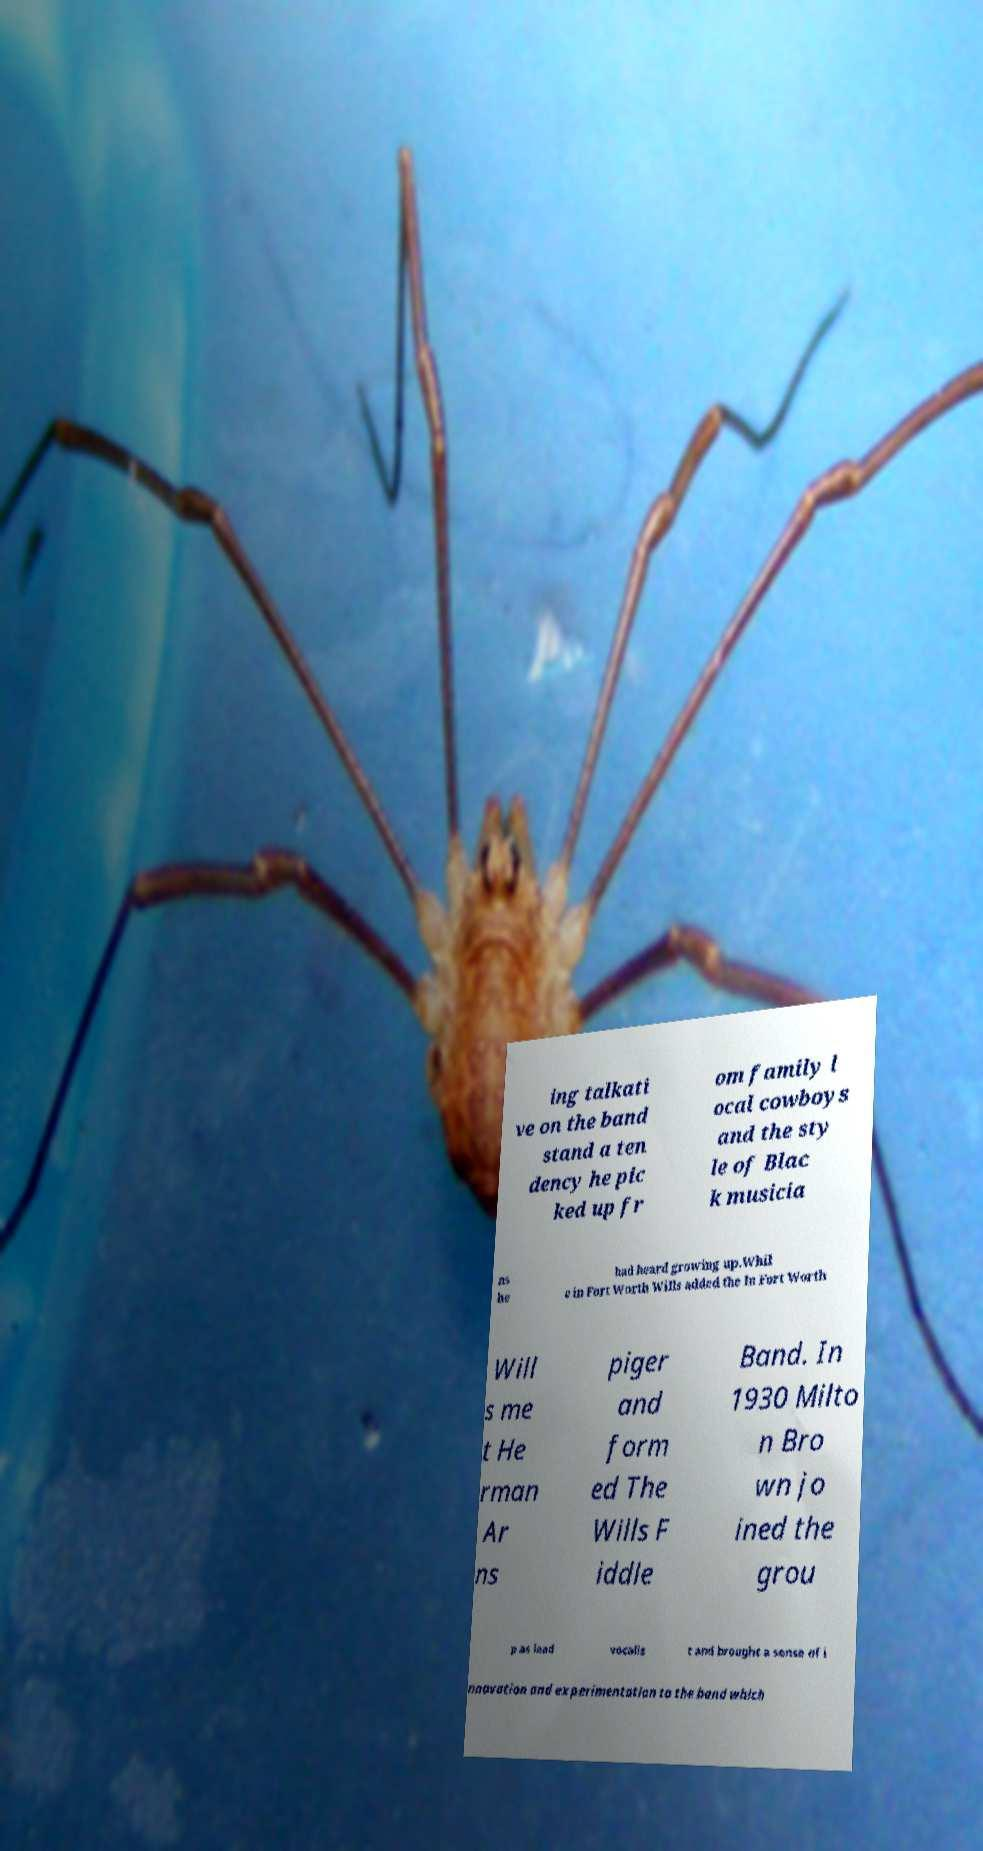Can you accurately transcribe the text from the provided image for me? ing talkati ve on the band stand a ten dency he pic ked up fr om family l ocal cowboys and the sty le of Blac k musicia ns he had heard growing up.Whil e in Fort Worth Wills added the In Fort Worth Will s me t He rman Ar ns piger and form ed The Wills F iddle Band. In 1930 Milto n Bro wn jo ined the grou p as lead vocalis t and brought a sense of i nnovation and experimentation to the band which 